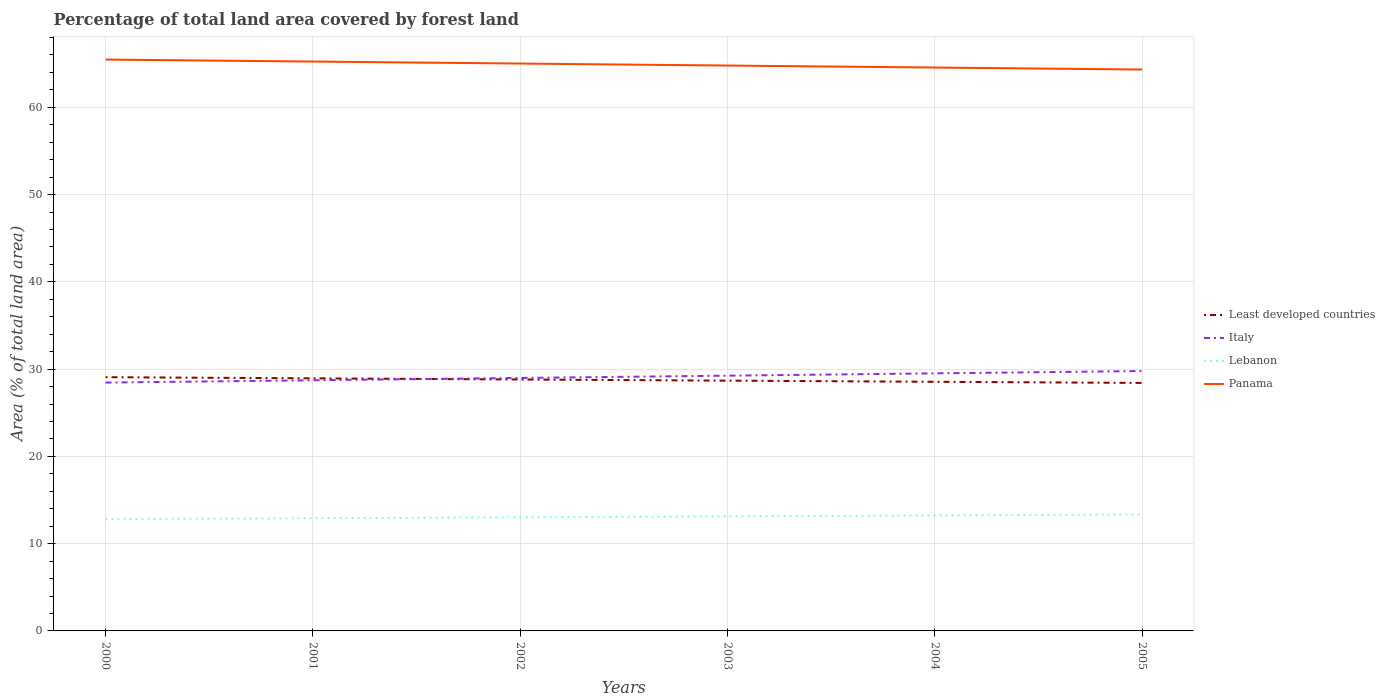Does the line corresponding to Italy intersect with the line corresponding to Least developed countries?
Your response must be concise. Yes. Across all years, what is the maximum percentage of forest land in Least developed countries?
Your answer should be very brief. 28.41. What is the total percentage of forest land in Italy in the graph?
Give a very brief answer. -0.27. What is the difference between the highest and the second highest percentage of forest land in Italy?
Keep it short and to the point. 1.32. Is the percentage of forest land in Lebanon strictly greater than the percentage of forest land in Least developed countries over the years?
Provide a succinct answer. Yes. How many years are there in the graph?
Your answer should be very brief. 6. Are the values on the major ticks of Y-axis written in scientific E-notation?
Your answer should be compact. No. Does the graph contain any zero values?
Ensure brevity in your answer.  No. Where does the legend appear in the graph?
Ensure brevity in your answer.  Center right. How are the legend labels stacked?
Offer a very short reply. Vertical. What is the title of the graph?
Ensure brevity in your answer.  Percentage of total land area covered by forest land. Does "Antigua and Barbuda" appear as one of the legend labels in the graph?
Make the answer very short. No. What is the label or title of the Y-axis?
Offer a terse response. Area (% of total land area). What is the Area (% of total land area) in Least developed countries in 2000?
Your answer should be very brief. 29.08. What is the Area (% of total land area) in Italy in 2000?
Keep it short and to the point. 28.46. What is the Area (% of total land area) in Lebanon in 2000?
Your answer should be compact. 12.81. What is the Area (% of total land area) in Panama in 2000?
Make the answer very short. 65.47. What is the Area (% of total land area) of Least developed countries in 2001?
Keep it short and to the point. 28.94. What is the Area (% of total land area) of Italy in 2001?
Provide a succinct answer. 28.72. What is the Area (% of total land area) of Lebanon in 2001?
Your answer should be compact. 12.91. What is the Area (% of total land area) of Panama in 2001?
Give a very brief answer. 65.24. What is the Area (% of total land area) of Least developed countries in 2002?
Provide a succinct answer. 28.81. What is the Area (% of total land area) in Italy in 2002?
Ensure brevity in your answer.  28.99. What is the Area (% of total land area) of Lebanon in 2002?
Your response must be concise. 13.02. What is the Area (% of total land area) in Panama in 2002?
Offer a very short reply. 65.01. What is the Area (% of total land area) in Least developed countries in 2003?
Keep it short and to the point. 28.68. What is the Area (% of total land area) in Italy in 2003?
Offer a very short reply. 29.25. What is the Area (% of total land area) of Lebanon in 2003?
Your response must be concise. 13.13. What is the Area (% of total land area) of Panama in 2003?
Offer a terse response. 64.78. What is the Area (% of total land area) of Least developed countries in 2004?
Your answer should be very brief. 28.55. What is the Area (% of total land area) in Italy in 2004?
Provide a short and direct response. 29.51. What is the Area (% of total land area) of Lebanon in 2004?
Offer a very short reply. 13.24. What is the Area (% of total land area) in Panama in 2004?
Keep it short and to the point. 64.55. What is the Area (% of total land area) of Least developed countries in 2005?
Keep it short and to the point. 28.41. What is the Area (% of total land area) of Italy in 2005?
Ensure brevity in your answer.  29.78. What is the Area (% of total land area) in Lebanon in 2005?
Ensure brevity in your answer.  13.34. What is the Area (% of total land area) of Panama in 2005?
Provide a succinct answer. 64.33. Across all years, what is the maximum Area (% of total land area) of Least developed countries?
Give a very brief answer. 29.08. Across all years, what is the maximum Area (% of total land area) of Italy?
Keep it short and to the point. 29.78. Across all years, what is the maximum Area (% of total land area) in Lebanon?
Ensure brevity in your answer.  13.34. Across all years, what is the maximum Area (% of total land area) in Panama?
Make the answer very short. 65.47. Across all years, what is the minimum Area (% of total land area) of Least developed countries?
Your answer should be compact. 28.41. Across all years, what is the minimum Area (% of total land area) in Italy?
Keep it short and to the point. 28.46. Across all years, what is the minimum Area (% of total land area) of Lebanon?
Give a very brief answer. 12.81. Across all years, what is the minimum Area (% of total land area) in Panama?
Your response must be concise. 64.33. What is the total Area (% of total land area) of Least developed countries in the graph?
Provide a short and direct response. 172.47. What is the total Area (% of total land area) in Italy in the graph?
Your answer should be compact. 174.7. What is the total Area (% of total land area) in Lebanon in the graph?
Offer a terse response. 78.45. What is the total Area (% of total land area) in Panama in the graph?
Your response must be concise. 389.39. What is the difference between the Area (% of total land area) in Least developed countries in 2000 and that in 2001?
Make the answer very short. 0.13. What is the difference between the Area (% of total land area) in Italy in 2000 and that in 2001?
Provide a succinct answer. -0.27. What is the difference between the Area (% of total land area) in Lebanon in 2000 and that in 2001?
Your response must be concise. -0.11. What is the difference between the Area (% of total land area) of Panama in 2000 and that in 2001?
Provide a short and direct response. 0.23. What is the difference between the Area (% of total land area) of Least developed countries in 2000 and that in 2002?
Make the answer very short. 0.27. What is the difference between the Area (% of total land area) in Italy in 2000 and that in 2002?
Your answer should be very brief. -0.53. What is the difference between the Area (% of total land area) of Lebanon in 2000 and that in 2002?
Offer a terse response. -0.22. What is the difference between the Area (% of total land area) of Panama in 2000 and that in 2002?
Your answer should be compact. 0.46. What is the difference between the Area (% of total land area) of Least developed countries in 2000 and that in 2003?
Give a very brief answer. 0.4. What is the difference between the Area (% of total land area) in Italy in 2000 and that in 2003?
Keep it short and to the point. -0.79. What is the difference between the Area (% of total land area) of Lebanon in 2000 and that in 2003?
Ensure brevity in your answer.  -0.32. What is the difference between the Area (% of total land area) of Panama in 2000 and that in 2003?
Make the answer very short. 0.69. What is the difference between the Area (% of total land area) in Least developed countries in 2000 and that in 2004?
Provide a succinct answer. 0.53. What is the difference between the Area (% of total land area) of Italy in 2000 and that in 2004?
Give a very brief answer. -1.06. What is the difference between the Area (% of total land area) of Lebanon in 2000 and that in 2004?
Provide a short and direct response. -0.43. What is the difference between the Area (% of total land area) of Panama in 2000 and that in 2004?
Your answer should be compact. 0.91. What is the difference between the Area (% of total land area) of Least developed countries in 2000 and that in 2005?
Offer a terse response. 0.66. What is the difference between the Area (% of total land area) of Italy in 2000 and that in 2005?
Offer a terse response. -1.32. What is the difference between the Area (% of total land area) of Lebanon in 2000 and that in 2005?
Give a very brief answer. -0.54. What is the difference between the Area (% of total land area) of Panama in 2000 and that in 2005?
Provide a succinct answer. 1.14. What is the difference between the Area (% of total land area) of Least developed countries in 2001 and that in 2002?
Your answer should be compact. 0.13. What is the difference between the Area (% of total land area) in Italy in 2001 and that in 2002?
Provide a short and direct response. -0.27. What is the difference between the Area (% of total land area) in Lebanon in 2001 and that in 2002?
Make the answer very short. -0.11. What is the difference between the Area (% of total land area) in Panama in 2001 and that in 2002?
Offer a terse response. 0.23. What is the difference between the Area (% of total land area) of Least developed countries in 2001 and that in 2003?
Your response must be concise. 0.27. What is the difference between the Area (% of total land area) of Italy in 2001 and that in 2003?
Provide a short and direct response. -0.53. What is the difference between the Area (% of total land area) in Lebanon in 2001 and that in 2003?
Your answer should be compact. -0.22. What is the difference between the Area (% of total land area) of Panama in 2001 and that in 2003?
Make the answer very short. 0.46. What is the difference between the Area (% of total land area) of Least developed countries in 2001 and that in 2004?
Keep it short and to the point. 0.4. What is the difference between the Area (% of total land area) of Italy in 2001 and that in 2004?
Offer a terse response. -0.79. What is the difference between the Area (% of total land area) of Lebanon in 2001 and that in 2004?
Ensure brevity in your answer.  -0.32. What is the difference between the Area (% of total land area) in Panama in 2001 and that in 2004?
Offer a terse response. 0.69. What is the difference between the Area (% of total land area) of Least developed countries in 2001 and that in 2005?
Your answer should be compact. 0.53. What is the difference between the Area (% of total land area) of Italy in 2001 and that in 2005?
Your response must be concise. -1.06. What is the difference between the Area (% of total land area) of Lebanon in 2001 and that in 2005?
Provide a succinct answer. -0.43. What is the difference between the Area (% of total land area) in Panama in 2001 and that in 2005?
Give a very brief answer. 0.91. What is the difference between the Area (% of total land area) of Least developed countries in 2002 and that in 2003?
Your response must be concise. 0.13. What is the difference between the Area (% of total land area) in Italy in 2002 and that in 2003?
Your answer should be very brief. -0.26. What is the difference between the Area (% of total land area) of Lebanon in 2002 and that in 2003?
Your response must be concise. -0.11. What is the difference between the Area (% of total land area) of Panama in 2002 and that in 2003?
Ensure brevity in your answer.  0.23. What is the difference between the Area (% of total land area) in Least developed countries in 2002 and that in 2004?
Give a very brief answer. 0.26. What is the difference between the Area (% of total land area) of Italy in 2002 and that in 2004?
Provide a succinct answer. -0.53. What is the difference between the Area (% of total land area) of Lebanon in 2002 and that in 2004?
Keep it short and to the point. -0.22. What is the difference between the Area (% of total land area) in Panama in 2002 and that in 2004?
Provide a succinct answer. 0.46. What is the difference between the Area (% of total land area) in Least developed countries in 2002 and that in 2005?
Your answer should be very brief. 0.4. What is the difference between the Area (% of total land area) in Italy in 2002 and that in 2005?
Provide a short and direct response. -0.79. What is the difference between the Area (% of total land area) of Lebanon in 2002 and that in 2005?
Give a very brief answer. -0.32. What is the difference between the Area (% of total land area) of Panama in 2002 and that in 2005?
Provide a short and direct response. 0.69. What is the difference between the Area (% of total land area) of Least developed countries in 2003 and that in 2004?
Offer a very short reply. 0.13. What is the difference between the Area (% of total land area) in Italy in 2003 and that in 2004?
Keep it short and to the point. -0.27. What is the difference between the Area (% of total land area) of Lebanon in 2003 and that in 2004?
Make the answer very short. -0.11. What is the difference between the Area (% of total land area) of Panama in 2003 and that in 2004?
Your response must be concise. 0.23. What is the difference between the Area (% of total land area) in Least developed countries in 2003 and that in 2005?
Ensure brevity in your answer.  0.26. What is the difference between the Area (% of total land area) in Italy in 2003 and that in 2005?
Keep it short and to the point. -0.53. What is the difference between the Area (% of total land area) of Lebanon in 2003 and that in 2005?
Keep it short and to the point. -0.22. What is the difference between the Area (% of total land area) in Panama in 2003 and that in 2005?
Offer a terse response. 0.46. What is the difference between the Area (% of total land area) in Least developed countries in 2004 and that in 2005?
Give a very brief answer. 0.13. What is the difference between the Area (% of total land area) of Italy in 2004 and that in 2005?
Your answer should be compact. -0.27. What is the difference between the Area (% of total land area) of Lebanon in 2004 and that in 2005?
Make the answer very short. -0.11. What is the difference between the Area (% of total land area) of Panama in 2004 and that in 2005?
Offer a very short reply. 0.23. What is the difference between the Area (% of total land area) in Least developed countries in 2000 and the Area (% of total land area) in Italy in 2001?
Offer a very short reply. 0.35. What is the difference between the Area (% of total land area) of Least developed countries in 2000 and the Area (% of total land area) of Lebanon in 2001?
Offer a very short reply. 16.16. What is the difference between the Area (% of total land area) of Least developed countries in 2000 and the Area (% of total land area) of Panama in 2001?
Ensure brevity in your answer.  -36.17. What is the difference between the Area (% of total land area) in Italy in 2000 and the Area (% of total land area) in Lebanon in 2001?
Your answer should be compact. 15.54. What is the difference between the Area (% of total land area) of Italy in 2000 and the Area (% of total land area) of Panama in 2001?
Offer a terse response. -36.79. What is the difference between the Area (% of total land area) in Lebanon in 2000 and the Area (% of total land area) in Panama in 2001?
Your response must be concise. -52.44. What is the difference between the Area (% of total land area) in Least developed countries in 2000 and the Area (% of total land area) in Italy in 2002?
Make the answer very short. 0.09. What is the difference between the Area (% of total land area) in Least developed countries in 2000 and the Area (% of total land area) in Lebanon in 2002?
Your answer should be compact. 16.05. What is the difference between the Area (% of total land area) in Least developed countries in 2000 and the Area (% of total land area) in Panama in 2002?
Give a very brief answer. -35.94. What is the difference between the Area (% of total land area) in Italy in 2000 and the Area (% of total land area) in Lebanon in 2002?
Provide a short and direct response. 15.43. What is the difference between the Area (% of total land area) in Italy in 2000 and the Area (% of total land area) in Panama in 2002?
Make the answer very short. -36.56. What is the difference between the Area (% of total land area) in Lebanon in 2000 and the Area (% of total land area) in Panama in 2002?
Your answer should be very brief. -52.21. What is the difference between the Area (% of total land area) of Least developed countries in 2000 and the Area (% of total land area) of Italy in 2003?
Your response must be concise. -0.17. What is the difference between the Area (% of total land area) in Least developed countries in 2000 and the Area (% of total land area) in Lebanon in 2003?
Make the answer very short. 15.95. What is the difference between the Area (% of total land area) of Least developed countries in 2000 and the Area (% of total land area) of Panama in 2003?
Give a very brief answer. -35.71. What is the difference between the Area (% of total land area) of Italy in 2000 and the Area (% of total land area) of Lebanon in 2003?
Your answer should be very brief. 15.33. What is the difference between the Area (% of total land area) of Italy in 2000 and the Area (% of total land area) of Panama in 2003?
Ensure brevity in your answer.  -36.33. What is the difference between the Area (% of total land area) in Lebanon in 2000 and the Area (% of total land area) in Panama in 2003?
Keep it short and to the point. -51.98. What is the difference between the Area (% of total land area) in Least developed countries in 2000 and the Area (% of total land area) in Italy in 2004?
Keep it short and to the point. -0.44. What is the difference between the Area (% of total land area) of Least developed countries in 2000 and the Area (% of total land area) of Lebanon in 2004?
Offer a terse response. 15.84. What is the difference between the Area (% of total land area) of Least developed countries in 2000 and the Area (% of total land area) of Panama in 2004?
Provide a succinct answer. -35.48. What is the difference between the Area (% of total land area) in Italy in 2000 and the Area (% of total land area) in Lebanon in 2004?
Your answer should be very brief. 15.22. What is the difference between the Area (% of total land area) in Italy in 2000 and the Area (% of total land area) in Panama in 2004?
Ensure brevity in your answer.  -36.1. What is the difference between the Area (% of total land area) of Lebanon in 2000 and the Area (% of total land area) of Panama in 2004?
Your answer should be compact. -51.75. What is the difference between the Area (% of total land area) of Least developed countries in 2000 and the Area (% of total land area) of Italy in 2005?
Give a very brief answer. -0.7. What is the difference between the Area (% of total land area) in Least developed countries in 2000 and the Area (% of total land area) in Lebanon in 2005?
Offer a very short reply. 15.73. What is the difference between the Area (% of total land area) of Least developed countries in 2000 and the Area (% of total land area) of Panama in 2005?
Your response must be concise. -35.25. What is the difference between the Area (% of total land area) in Italy in 2000 and the Area (% of total land area) in Lebanon in 2005?
Make the answer very short. 15.11. What is the difference between the Area (% of total land area) in Italy in 2000 and the Area (% of total land area) in Panama in 2005?
Your response must be concise. -35.87. What is the difference between the Area (% of total land area) in Lebanon in 2000 and the Area (% of total land area) in Panama in 2005?
Provide a short and direct response. -51.52. What is the difference between the Area (% of total land area) in Least developed countries in 2001 and the Area (% of total land area) in Italy in 2002?
Offer a very short reply. -0.04. What is the difference between the Area (% of total land area) in Least developed countries in 2001 and the Area (% of total land area) in Lebanon in 2002?
Ensure brevity in your answer.  15.92. What is the difference between the Area (% of total land area) in Least developed countries in 2001 and the Area (% of total land area) in Panama in 2002?
Offer a terse response. -36.07. What is the difference between the Area (% of total land area) in Italy in 2001 and the Area (% of total land area) in Panama in 2002?
Provide a short and direct response. -36.29. What is the difference between the Area (% of total land area) in Lebanon in 2001 and the Area (% of total land area) in Panama in 2002?
Your response must be concise. -52.1. What is the difference between the Area (% of total land area) of Least developed countries in 2001 and the Area (% of total land area) of Italy in 2003?
Offer a very short reply. -0.31. What is the difference between the Area (% of total land area) in Least developed countries in 2001 and the Area (% of total land area) in Lebanon in 2003?
Make the answer very short. 15.81. What is the difference between the Area (% of total land area) of Least developed countries in 2001 and the Area (% of total land area) of Panama in 2003?
Give a very brief answer. -35.84. What is the difference between the Area (% of total land area) in Italy in 2001 and the Area (% of total land area) in Lebanon in 2003?
Provide a succinct answer. 15.59. What is the difference between the Area (% of total land area) of Italy in 2001 and the Area (% of total land area) of Panama in 2003?
Offer a terse response. -36.06. What is the difference between the Area (% of total land area) in Lebanon in 2001 and the Area (% of total land area) in Panama in 2003?
Your response must be concise. -51.87. What is the difference between the Area (% of total land area) of Least developed countries in 2001 and the Area (% of total land area) of Italy in 2004?
Ensure brevity in your answer.  -0.57. What is the difference between the Area (% of total land area) in Least developed countries in 2001 and the Area (% of total land area) in Lebanon in 2004?
Provide a succinct answer. 15.71. What is the difference between the Area (% of total land area) in Least developed countries in 2001 and the Area (% of total land area) in Panama in 2004?
Your answer should be compact. -35.61. What is the difference between the Area (% of total land area) in Italy in 2001 and the Area (% of total land area) in Lebanon in 2004?
Your answer should be compact. 15.48. What is the difference between the Area (% of total land area) of Italy in 2001 and the Area (% of total land area) of Panama in 2004?
Provide a succinct answer. -35.83. What is the difference between the Area (% of total land area) in Lebanon in 2001 and the Area (% of total land area) in Panama in 2004?
Your response must be concise. -51.64. What is the difference between the Area (% of total land area) in Least developed countries in 2001 and the Area (% of total land area) in Italy in 2005?
Ensure brevity in your answer.  -0.84. What is the difference between the Area (% of total land area) of Least developed countries in 2001 and the Area (% of total land area) of Lebanon in 2005?
Keep it short and to the point. 15.6. What is the difference between the Area (% of total land area) of Least developed countries in 2001 and the Area (% of total land area) of Panama in 2005?
Make the answer very short. -35.38. What is the difference between the Area (% of total land area) in Italy in 2001 and the Area (% of total land area) in Lebanon in 2005?
Keep it short and to the point. 15.38. What is the difference between the Area (% of total land area) in Italy in 2001 and the Area (% of total land area) in Panama in 2005?
Offer a very short reply. -35.61. What is the difference between the Area (% of total land area) of Lebanon in 2001 and the Area (% of total land area) of Panama in 2005?
Your answer should be very brief. -51.41. What is the difference between the Area (% of total land area) of Least developed countries in 2002 and the Area (% of total land area) of Italy in 2003?
Give a very brief answer. -0.44. What is the difference between the Area (% of total land area) in Least developed countries in 2002 and the Area (% of total land area) in Lebanon in 2003?
Give a very brief answer. 15.68. What is the difference between the Area (% of total land area) of Least developed countries in 2002 and the Area (% of total land area) of Panama in 2003?
Your response must be concise. -35.97. What is the difference between the Area (% of total land area) in Italy in 2002 and the Area (% of total land area) in Lebanon in 2003?
Ensure brevity in your answer.  15.86. What is the difference between the Area (% of total land area) in Italy in 2002 and the Area (% of total land area) in Panama in 2003?
Your answer should be very brief. -35.8. What is the difference between the Area (% of total land area) of Lebanon in 2002 and the Area (% of total land area) of Panama in 2003?
Make the answer very short. -51.76. What is the difference between the Area (% of total land area) in Least developed countries in 2002 and the Area (% of total land area) in Italy in 2004?
Your answer should be compact. -0.7. What is the difference between the Area (% of total land area) of Least developed countries in 2002 and the Area (% of total land area) of Lebanon in 2004?
Your response must be concise. 15.57. What is the difference between the Area (% of total land area) in Least developed countries in 2002 and the Area (% of total land area) in Panama in 2004?
Your answer should be compact. -35.74. What is the difference between the Area (% of total land area) in Italy in 2002 and the Area (% of total land area) in Lebanon in 2004?
Your answer should be very brief. 15.75. What is the difference between the Area (% of total land area) in Italy in 2002 and the Area (% of total land area) in Panama in 2004?
Provide a short and direct response. -35.57. What is the difference between the Area (% of total land area) of Lebanon in 2002 and the Area (% of total land area) of Panama in 2004?
Keep it short and to the point. -51.53. What is the difference between the Area (% of total land area) in Least developed countries in 2002 and the Area (% of total land area) in Italy in 2005?
Offer a very short reply. -0.97. What is the difference between the Area (% of total land area) of Least developed countries in 2002 and the Area (% of total land area) of Lebanon in 2005?
Provide a succinct answer. 15.47. What is the difference between the Area (% of total land area) in Least developed countries in 2002 and the Area (% of total land area) in Panama in 2005?
Ensure brevity in your answer.  -35.52. What is the difference between the Area (% of total land area) of Italy in 2002 and the Area (% of total land area) of Lebanon in 2005?
Keep it short and to the point. 15.64. What is the difference between the Area (% of total land area) in Italy in 2002 and the Area (% of total land area) in Panama in 2005?
Your answer should be compact. -35.34. What is the difference between the Area (% of total land area) of Lebanon in 2002 and the Area (% of total land area) of Panama in 2005?
Provide a succinct answer. -51.31. What is the difference between the Area (% of total land area) in Least developed countries in 2003 and the Area (% of total land area) in Italy in 2004?
Your response must be concise. -0.84. What is the difference between the Area (% of total land area) of Least developed countries in 2003 and the Area (% of total land area) of Lebanon in 2004?
Provide a succinct answer. 15.44. What is the difference between the Area (% of total land area) in Least developed countries in 2003 and the Area (% of total land area) in Panama in 2004?
Make the answer very short. -35.88. What is the difference between the Area (% of total land area) in Italy in 2003 and the Area (% of total land area) in Lebanon in 2004?
Your answer should be very brief. 16.01. What is the difference between the Area (% of total land area) of Italy in 2003 and the Area (% of total land area) of Panama in 2004?
Offer a very short reply. -35.31. What is the difference between the Area (% of total land area) in Lebanon in 2003 and the Area (% of total land area) in Panama in 2004?
Provide a succinct answer. -51.43. What is the difference between the Area (% of total land area) in Least developed countries in 2003 and the Area (% of total land area) in Italy in 2005?
Your answer should be compact. -1.1. What is the difference between the Area (% of total land area) of Least developed countries in 2003 and the Area (% of total land area) of Lebanon in 2005?
Give a very brief answer. 15.33. What is the difference between the Area (% of total land area) of Least developed countries in 2003 and the Area (% of total land area) of Panama in 2005?
Provide a succinct answer. -35.65. What is the difference between the Area (% of total land area) in Italy in 2003 and the Area (% of total land area) in Lebanon in 2005?
Your response must be concise. 15.9. What is the difference between the Area (% of total land area) of Italy in 2003 and the Area (% of total land area) of Panama in 2005?
Give a very brief answer. -35.08. What is the difference between the Area (% of total land area) in Lebanon in 2003 and the Area (% of total land area) in Panama in 2005?
Ensure brevity in your answer.  -51.2. What is the difference between the Area (% of total land area) of Least developed countries in 2004 and the Area (% of total land area) of Italy in 2005?
Offer a very short reply. -1.23. What is the difference between the Area (% of total land area) in Least developed countries in 2004 and the Area (% of total land area) in Lebanon in 2005?
Keep it short and to the point. 15.2. What is the difference between the Area (% of total land area) in Least developed countries in 2004 and the Area (% of total land area) in Panama in 2005?
Make the answer very short. -35.78. What is the difference between the Area (% of total land area) of Italy in 2004 and the Area (% of total land area) of Lebanon in 2005?
Offer a terse response. 16.17. What is the difference between the Area (% of total land area) in Italy in 2004 and the Area (% of total land area) in Panama in 2005?
Your answer should be very brief. -34.81. What is the difference between the Area (% of total land area) of Lebanon in 2004 and the Area (% of total land area) of Panama in 2005?
Your answer should be very brief. -51.09. What is the average Area (% of total land area) of Least developed countries per year?
Your response must be concise. 28.74. What is the average Area (% of total land area) of Italy per year?
Your answer should be very brief. 29.12. What is the average Area (% of total land area) in Lebanon per year?
Provide a succinct answer. 13.07. What is the average Area (% of total land area) in Panama per year?
Provide a succinct answer. 64.9. In the year 2000, what is the difference between the Area (% of total land area) in Least developed countries and Area (% of total land area) in Italy?
Offer a terse response. 0.62. In the year 2000, what is the difference between the Area (% of total land area) of Least developed countries and Area (% of total land area) of Lebanon?
Your answer should be compact. 16.27. In the year 2000, what is the difference between the Area (% of total land area) in Least developed countries and Area (% of total land area) in Panama?
Offer a terse response. -36.39. In the year 2000, what is the difference between the Area (% of total land area) of Italy and Area (% of total land area) of Lebanon?
Give a very brief answer. 15.65. In the year 2000, what is the difference between the Area (% of total land area) in Italy and Area (% of total land area) in Panama?
Your answer should be very brief. -37.01. In the year 2000, what is the difference between the Area (% of total land area) of Lebanon and Area (% of total land area) of Panama?
Provide a succinct answer. -52.66. In the year 2001, what is the difference between the Area (% of total land area) in Least developed countries and Area (% of total land area) in Italy?
Ensure brevity in your answer.  0.22. In the year 2001, what is the difference between the Area (% of total land area) of Least developed countries and Area (% of total land area) of Lebanon?
Keep it short and to the point. 16.03. In the year 2001, what is the difference between the Area (% of total land area) of Least developed countries and Area (% of total land area) of Panama?
Make the answer very short. -36.3. In the year 2001, what is the difference between the Area (% of total land area) of Italy and Area (% of total land area) of Lebanon?
Give a very brief answer. 15.81. In the year 2001, what is the difference between the Area (% of total land area) in Italy and Area (% of total land area) in Panama?
Offer a very short reply. -36.52. In the year 2001, what is the difference between the Area (% of total land area) of Lebanon and Area (% of total land area) of Panama?
Offer a very short reply. -52.33. In the year 2002, what is the difference between the Area (% of total land area) of Least developed countries and Area (% of total land area) of Italy?
Your answer should be compact. -0.18. In the year 2002, what is the difference between the Area (% of total land area) in Least developed countries and Area (% of total land area) in Lebanon?
Make the answer very short. 15.79. In the year 2002, what is the difference between the Area (% of total land area) in Least developed countries and Area (% of total land area) in Panama?
Keep it short and to the point. -36.2. In the year 2002, what is the difference between the Area (% of total land area) of Italy and Area (% of total land area) of Lebanon?
Offer a very short reply. 15.97. In the year 2002, what is the difference between the Area (% of total land area) of Italy and Area (% of total land area) of Panama?
Your response must be concise. -36.03. In the year 2002, what is the difference between the Area (% of total land area) in Lebanon and Area (% of total land area) in Panama?
Offer a terse response. -51.99. In the year 2003, what is the difference between the Area (% of total land area) in Least developed countries and Area (% of total land area) in Italy?
Provide a short and direct response. -0.57. In the year 2003, what is the difference between the Area (% of total land area) of Least developed countries and Area (% of total land area) of Lebanon?
Provide a succinct answer. 15.55. In the year 2003, what is the difference between the Area (% of total land area) of Least developed countries and Area (% of total land area) of Panama?
Ensure brevity in your answer.  -36.11. In the year 2003, what is the difference between the Area (% of total land area) of Italy and Area (% of total land area) of Lebanon?
Provide a succinct answer. 16.12. In the year 2003, what is the difference between the Area (% of total land area) in Italy and Area (% of total land area) in Panama?
Your answer should be compact. -35.54. In the year 2003, what is the difference between the Area (% of total land area) in Lebanon and Area (% of total land area) in Panama?
Your answer should be very brief. -51.66. In the year 2004, what is the difference between the Area (% of total land area) of Least developed countries and Area (% of total land area) of Italy?
Offer a very short reply. -0.97. In the year 2004, what is the difference between the Area (% of total land area) of Least developed countries and Area (% of total land area) of Lebanon?
Provide a short and direct response. 15.31. In the year 2004, what is the difference between the Area (% of total land area) in Least developed countries and Area (% of total land area) in Panama?
Your answer should be compact. -36.01. In the year 2004, what is the difference between the Area (% of total land area) in Italy and Area (% of total land area) in Lebanon?
Ensure brevity in your answer.  16.28. In the year 2004, what is the difference between the Area (% of total land area) in Italy and Area (% of total land area) in Panama?
Offer a very short reply. -35.04. In the year 2004, what is the difference between the Area (% of total land area) of Lebanon and Area (% of total land area) of Panama?
Keep it short and to the point. -51.32. In the year 2005, what is the difference between the Area (% of total land area) of Least developed countries and Area (% of total land area) of Italy?
Provide a succinct answer. -1.36. In the year 2005, what is the difference between the Area (% of total land area) in Least developed countries and Area (% of total land area) in Lebanon?
Provide a succinct answer. 15.07. In the year 2005, what is the difference between the Area (% of total land area) of Least developed countries and Area (% of total land area) of Panama?
Give a very brief answer. -35.91. In the year 2005, what is the difference between the Area (% of total land area) in Italy and Area (% of total land area) in Lebanon?
Your answer should be very brief. 16.44. In the year 2005, what is the difference between the Area (% of total land area) of Italy and Area (% of total land area) of Panama?
Ensure brevity in your answer.  -34.55. In the year 2005, what is the difference between the Area (% of total land area) in Lebanon and Area (% of total land area) in Panama?
Provide a short and direct response. -50.98. What is the ratio of the Area (% of total land area) of Italy in 2000 to that in 2001?
Provide a succinct answer. 0.99. What is the ratio of the Area (% of total land area) in Least developed countries in 2000 to that in 2002?
Provide a short and direct response. 1.01. What is the ratio of the Area (% of total land area) of Italy in 2000 to that in 2002?
Your answer should be very brief. 0.98. What is the ratio of the Area (% of total land area) of Lebanon in 2000 to that in 2002?
Give a very brief answer. 0.98. What is the ratio of the Area (% of total land area) of Least developed countries in 2000 to that in 2003?
Keep it short and to the point. 1.01. What is the ratio of the Area (% of total land area) of Italy in 2000 to that in 2003?
Make the answer very short. 0.97. What is the ratio of the Area (% of total land area) in Lebanon in 2000 to that in 2003?
Your response must be concise. 0.98. What is the ratio of the Area (% of total land area) of Panama in 2000 to that in 2003?
Your answer should be compact. 1.01. What is the ratio of the Area (% of total land area) of Least developed countries in 2000 to that in 2004?
Provide a short and direct response. 1.02. What is the ratio of the Area (% of total land area) of Italy in 2000 to that in 2004?
Your answer should be compact. 0.96. What is the ratio of the Area (% of total land area) of Lebanon in 2000 to that in 2004?
Keep it short and to the point. 0.97. What is the ratio of the Area (% of total land area) in Panama in 2000 to that in 2004?
Offer a terse response. 1.01. What is the ratio of the Area (% of total land area) in Least developed countries in 2000 to that in 2005?
Your answer should be very brief. 1.02. What is the ratio of the Area (% of total land area) in Italy in 2000 to that in 2005?
Make the answer very short. 0.96. What is the ratio of the Area (% of total land area) in Lebanon in 2000 to that in 2005?
Keep it short and to the point. 0.96. What is the ratio of the Area (% of total land area) in Panama in 2000 to that in 2005?
Provide a succinct answer. 1.02. What is the ratio of the Area (% of total land area) in Least developed countries in 2001 to that in 2002?
Make the answer very short. 1. What is the ratio of the Area (% of total land area) in Italy in 2001 to that in 2002?
Make the answer very short. 0.99. What is the ratio of the Area (% of total land area) in Lebanon in 2001 to that in 2002?
Keep it short and to the point. 0.99. What is the ratio of the Area (% of total land area) in Panama in 2001 to that in 2002?
Give a very brief answer. 1. What is the ratio of the Area (% of total land area) in Least developed countries in 2001 to that in 2003?
Give a very brief answer. 1.01. What is the ratio of the Area (% of total land area) of Italy in 2001 to that in 2003?
Offer a very short reply. 0.98. What is the ratio of the Area (% of total land area) in Lebanon in 2001 to that in 2003?
Provide a short and direct response. 0.98. What is the ratio of the Area (% of total land area) in Panama in 2001 to that in 2003?
Provide a succinct answer. 1.01. What is the ratio of the Area (% of total land area) in Least developed countries in 2001 to that in 2004?
Your answer should be compact. 1.01. What is the ratio of the Area (% of total land area) of Italy in 2001 to that in 2004?
Your response must be concise. 0.97. What is the ratio of the Area (% of total land area) of Lebanon in 2001 to that in 2004?
Make the answer very short. 0.98. What is the ratio of the Area (% of total land area) of Panama in 2001 to that in 2004?
Offer a very short reply. 1.01. What is the ratio of the Area (% of total land area) of Least developed countries in 2001 to that in 2005?
Ensure brevity in your answer.  1.02. What is the ratio of the Area (% of total land area) of Italy in 2001 to that in 2005?
Your answer should be very brief. 0.96. What is the ratio of the Area (% of total land area) of Lebanon in 2001 to that in 2005?
Your answer should be compact. 0.97. What is the ratio of the Area (% of total land area) in Panama in 2001 to that in 2005?
Offer a very short reply. 1.01. What is the ratio of the Area (% of total land area) in Italy in 2002 to that in 2003?
Offer a very short reply. 0.99. What is the ratio of the Area (% of total land area) in Least developed countries in 2002 to that in 2004?
Ensure brevity in your answer.  1.01. What is the ratio of the Area (% of total land area) in Italy in 2002 to that in 2004?
Your response must be concise. 0.98. What is the ratio of the Area (% of total land area) of Lebanon in 2002 to that in 2004?
Offer a terse response. 0.98. What is the ratio of the Area (% of total land area) of Panama in 2002 to that in 2004?
Keep it short and to the point. 1.01. What is the ratio of the Area (% of total land area) in Least developed countries in 2002 to that in 2005?
Make the answer very short. 1.01. What is the ratio of the Area (% of total land area) in Italy in 2002 to that in 2005?
Provide a succinct answer. 0.97. What is the ratio of the Area (% of total land area) of Lebanon in 2002 to that in 2005?
Your answer should be very brief. 0.98. What is the ratio of the Area (% of total land area) in Panama in 2002 to that in 2005?
Give a very brief answer. 1.01. What is the ratio of the Area (% of total land area) of Least developed countries in 2003 to that in 2004?
Provide a short and direct response. 1. What is the ratio of the Area (% of total land area) in Italy in 2003 to that in 2004?
Offer a very short reply. 0.99. What is the ratio of the Area (% of total land area) of Lebanon in 2003 to that in 2004?
Provide a short and direct response. 0.99. What is the ratio of the Area (% of total land area) of Panama in 2003 to that in 2004?
Your response must be concise. 1. What is the ratio of the Area (% of total land area) of Least developed countries in 2003 to that in 2005?
Your response must be concise. 1.01. What is the ratio of the Area (% of total land area) of Italy in 2003 to that in 2005?
Provide a succinct answer. 0.98. What is the ratio of the Area (% of total land area) of Lebanon in 2003 to that in 2005?
Ensure brevity in your answer.  0.98. What is the ratio of the Area (% of total land area) in Panama in 2003 to that in 2005?
Give a very brief answer. 1.01. What is the ratio of the Area (% of total land area) in Least developed countries in 2004 to that in 2005?
Offer a very short reply. 1. What is the ratio of the Area (% of total land area) in Lebanon in 2004 to that in 2005?
Make the answer very short. 0.99. What is the ratio of the Area (% of total land area) in Panama in 2004 to that in 2005?
Your response must be concise. 1. What is the difference between the highest and the second highest Area (% of total land area) of Least developed countries?
Keep it short and to the point. 0.13. What is the difference between the highest and the second highest Area (% of total land area) of Italy?
Offer a terse response. 0.27. What is the difference between the highest and the second highest Area (% of total land area) in Lebanon?
Provide a succinct answer. 0.11. What is the difference between the highest and the second highest Area (% of total land area) in Panama?
Make the answer very short. 0.23. What is the difference between the highest and the lowest Area (% of total land area) in Least developed countries?
Offer a terse response. 0.66. What is the difference between the highest and the lowest Area (% of total land area) of Italy?
Provide a short and direct response. 1.32. What is the difference between the highest and the lowest Area (% of total land area) in Lebanon?
Your answer should be very brief. 0.54. What is the difference between the highest and the lowest Area (% of total land area) in Panama?
Your response must be concise. 1.14. 